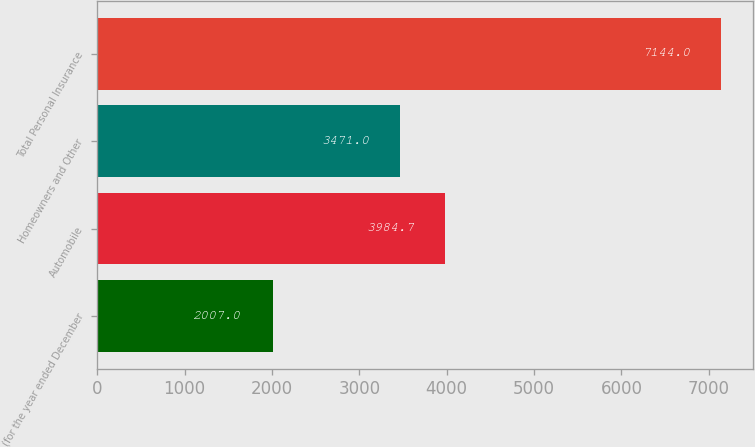Convert chart to OTSL. <chart><loc_0><loc_0><loc_500><loc_500><bar_chart><fcel>(for the year ended December<fcel>Automobile<fcel>Homeowners and Other<fcel>Total Personal Insurance<nl><fcel>2007<fcel>3984.7<fcel>3471<fcel>7144<nl></chart> 